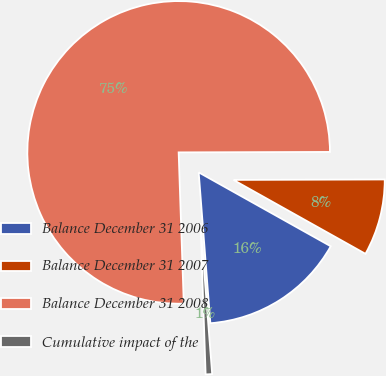<chart> <loc_0><loc_0><loc_500><loc_500><pie_chart><fcel>Balance December 31 2006<fcel>Balance December 31 2007<fcel>Balance December 31 2008<fcel>Cumulative impact of the<nl><fcel>15.65%<fcel>8.17%<fcel>75.5%<fcel>0.69%<nl></chart> 